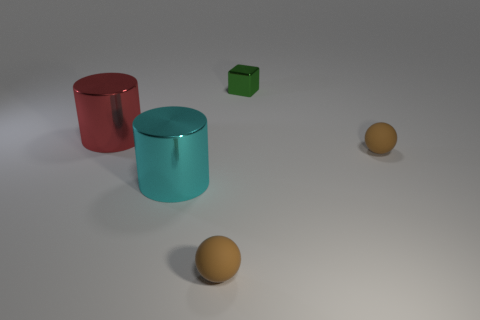What colors can be seen in the image and which object corresponds to each color? The image showcases objects in three distinct colors. There's a red cylinder, a teal cylinder, and a green cube. Additionally, there are two spheres that appear to be orange in color. 